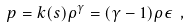<formula> <loc_0><loc_0><loc_500><loc_500>p = k ( s ) \rho ^ { \gamma } = ( \gamma - 1 ) \rho \epsilon \ ,</formula> 